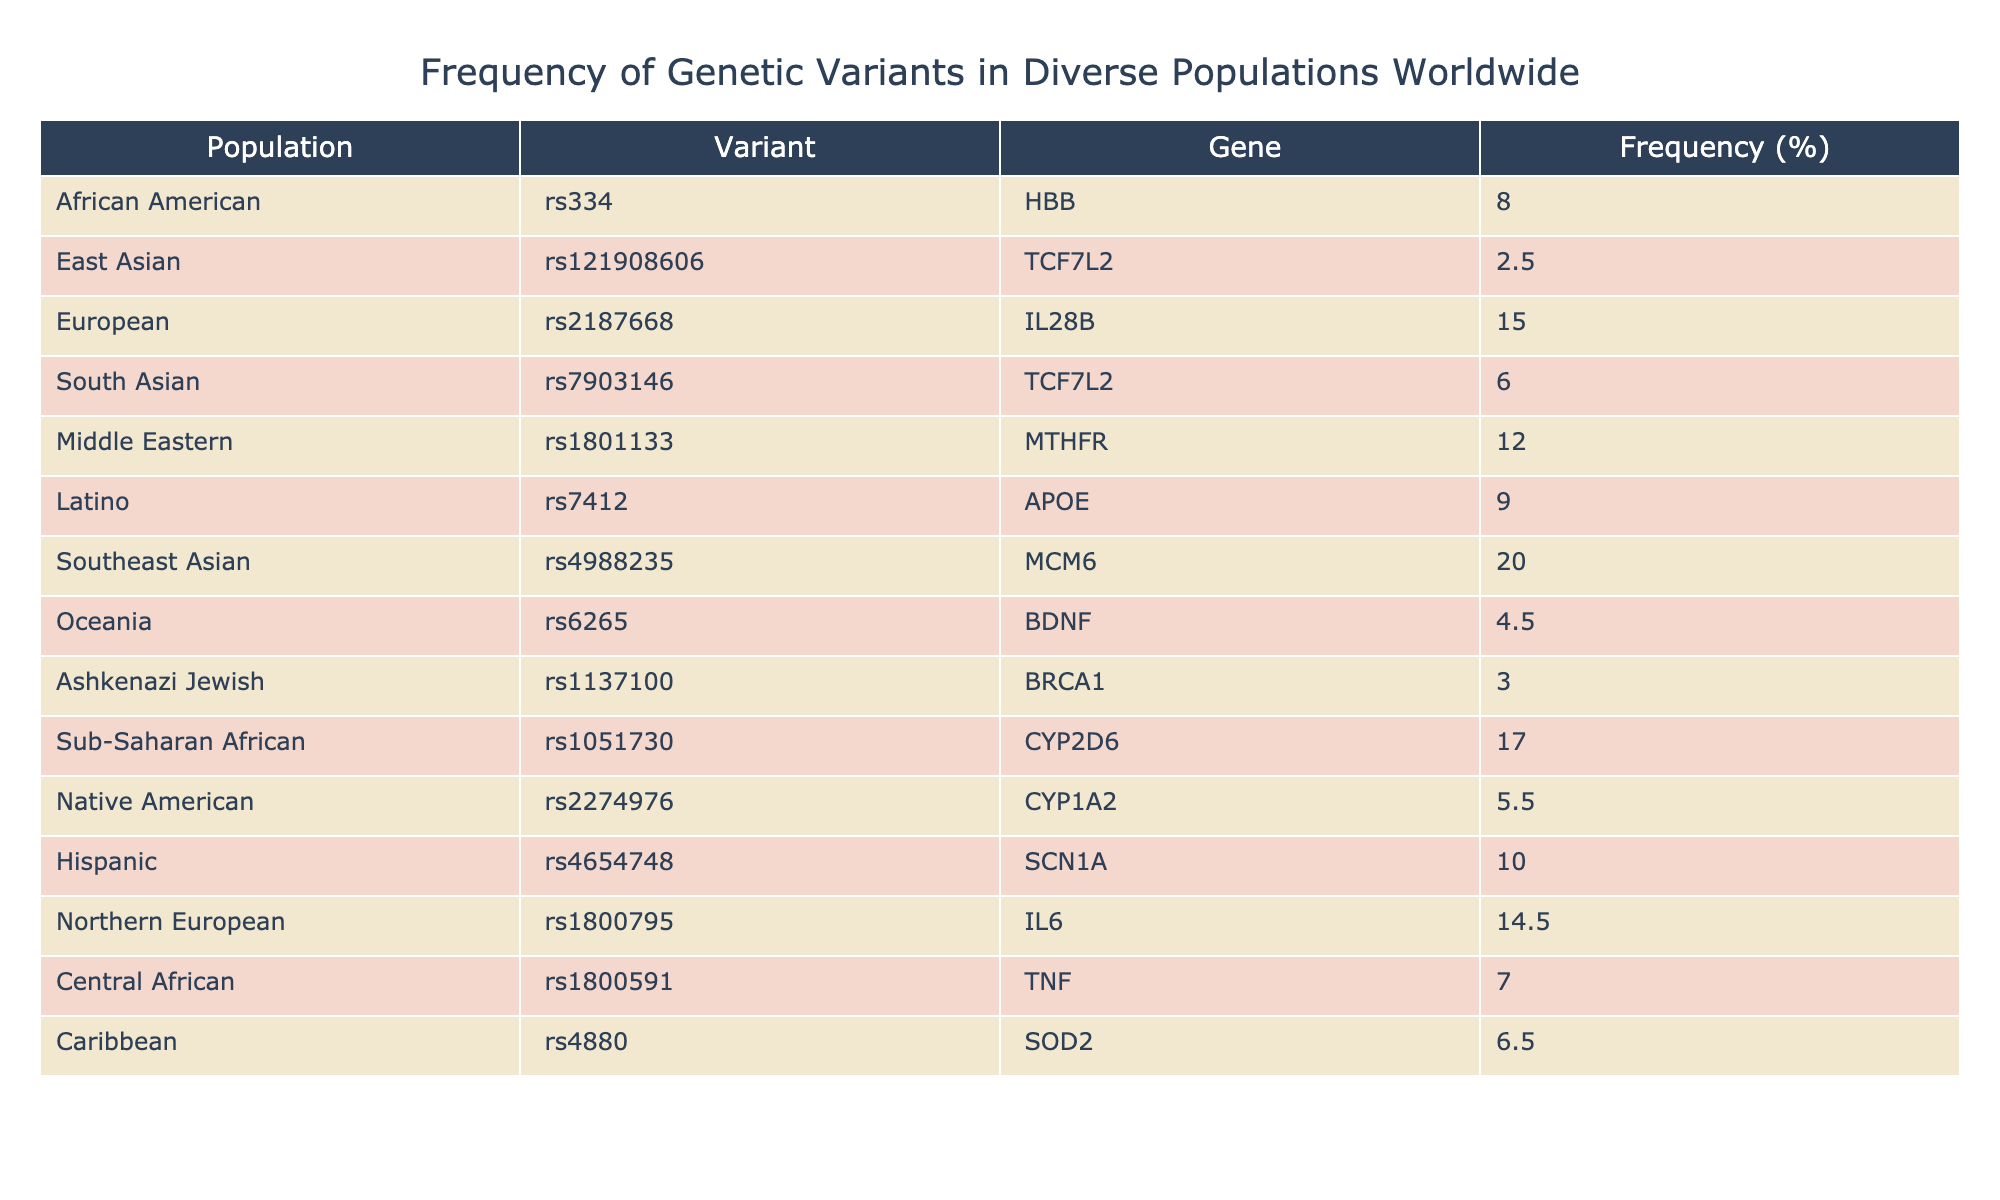What is the frequency of the rs334 variant in African Americans? According to the table, the frequency of the rs334 variant in African Americans is explicitly listed under that population as 8.0%.
Answer: 8.0% Which population has the highest frequency of a genetic variant? By examining the frequency percentages for each population, the Southeast Asian population has the highest frequency at 20.0% for the rs4988235 variant.
Answer: Southeast Asian What is the frequency of the rs2187668 variant in Europeans? The table indicates that the frequency of the rs2187668 variant in Europeans is 15.0%.
Answer: 15.0% Are there any populations with a frequency greater than 10% for genetic variants? Yes, when reviewing the table, both the Sub-Saharan African (17.0%) and Southeast Asian (20.0%) populations have frequencies greater than 10%.
Answer: Yes What is the average frequency of genetic variants for the populations listed in the table? To calculate the average frequency, add all the frequencies: (8.0 + 2.5 + 15.0 + 6.0 + 12.0 + 9.0 + 20.0 + 4.5 + 3.0 + 17.0 + 5.5 + 10.0 + 14.5 + 7.0 + 6.5) = 18.5, then divide by the total number of populations (15):  (151.0 / 15) = 10.07%.
Answer: 10.07% How many variants in total are listed for the Native American population? The table shows one entry for the Native American population, which indicates the presence of only one variant, rs2274976.
Answer: 1 Which population shows the lowest frequency of a genetic variant? Observing the frequencies listed, the Ashkenazi Jewish population has the lowest frequency at 3.0% for the rs1137100 variant.
Answer: Ashkenazi Jewish If you look at the frequencies of the rs6265 variant across the populations, which group has the lowest percentage? The rs6265 variant has a frequency of 4.5% in the Oceania population, which is the lowest frequency compared to other variants and their respective populations.
Answer: Oceania How does the frequency of the rs7903146 variant in South Asians compare to that in Europeans? The frequency of the rs7903146 variant in South Asians is 6.0% while in Europeans it is 15.0%, which means the frequency in Europeans is higher by 9.0%.
Answer: Europeans by 9.0% 